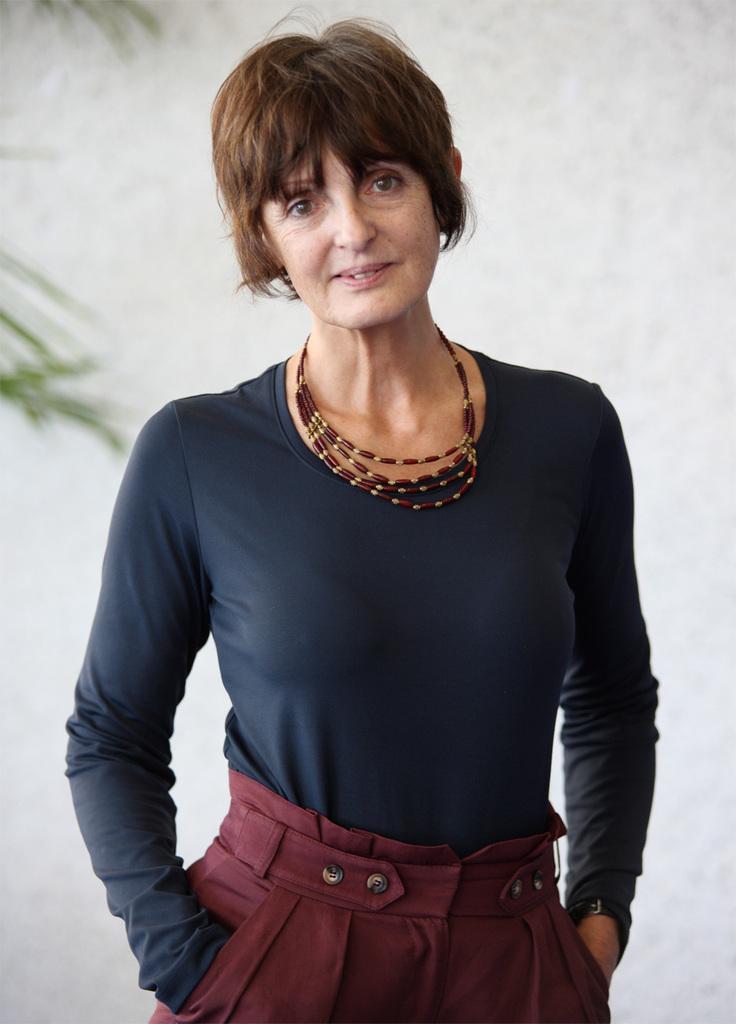Please provide a concise description of this image. In this image I can see there is a person standing and smiling. And at the back there are leaves and a wall. 